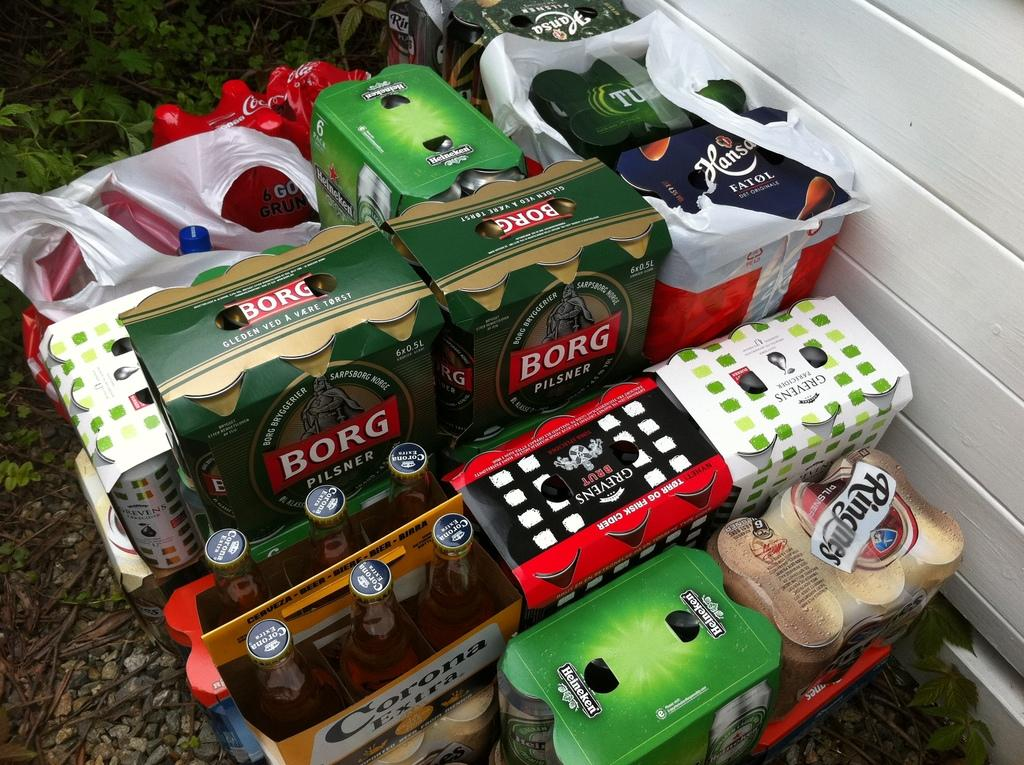What type of objects can be seen in the image? There are boxes, bottles, and plastic bags in the image. What natural elements are present in the image? There are plants, rocks, and branches in the image. What type of structure is visible in the image? There is a wall in the image. What color is the light emitted by the passenger in the image? There is no passenger or light source present in the image. 